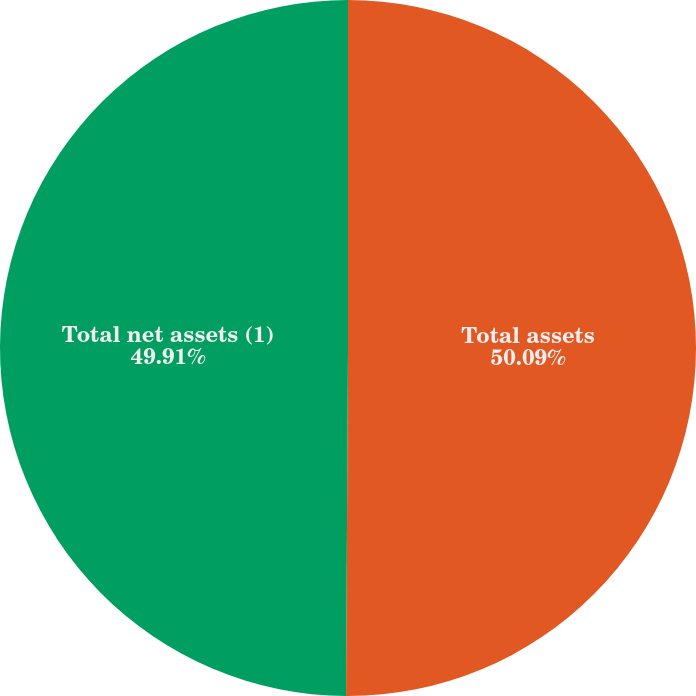<chart> <loc_0><loc_0><loc_500><loc_500><pie_chart><fcel>Total assets<fcel>Total net assets (1)<nl><fcel>50.09%<fcel>49.91%<nl></chart> 